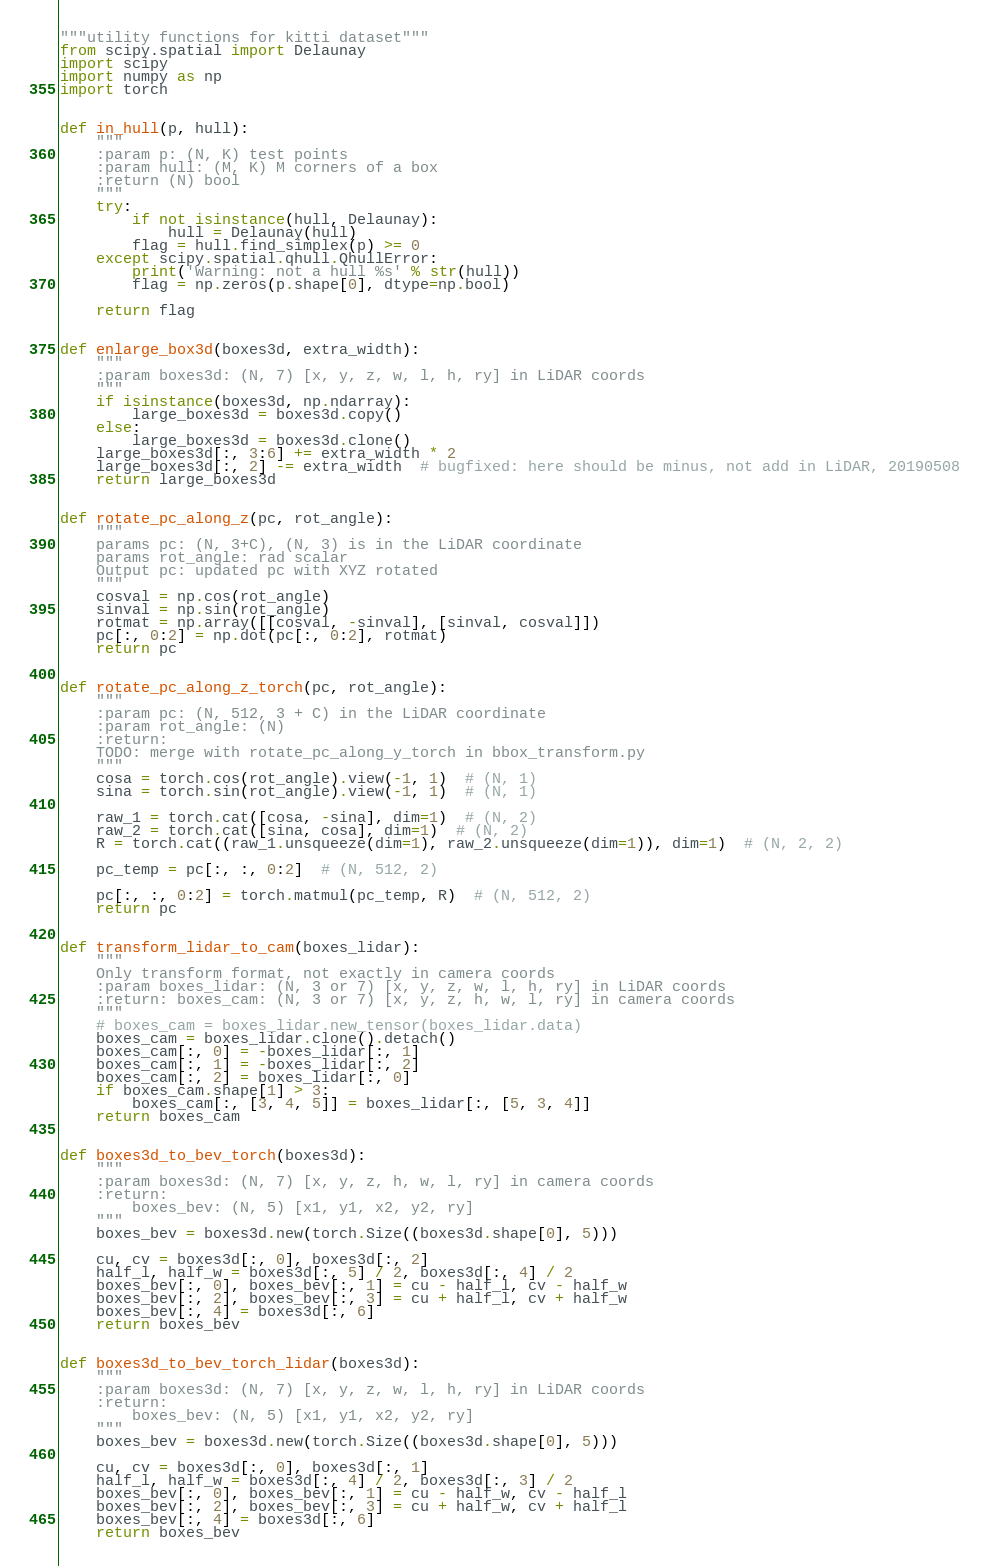<code> <loc_0><loc_0><loc_500><loc_500><_Python_>"""utility functions for kitti dataset"""
from scipy.spatial import Delaunay
import scipy
import numpy as np
import torch


def in_hull(p, hull):
    """
    :param p: (N, K) test points
    :param hull: (M, K) M corners of a box
    :return (N) bool
    """
    try:
        if not isinstance(hull, Delaunay):
            hull = Delaunay(hull)
        flag = hull.find_simplex(p) >= 0
    except scipy.spatial.qhull.QhullError:
        print('Warning: not a hull %s' % str(hull))
        flag = np.zeros(p.shape[0], dtype=np.bool)

    return flag


def enlarge_box3d(boxes3d, extra_width):
    """
    :param boxes3d: (N, 7) [x, y, z, w, l, h, ry] in LiDAR coords
    """
    if isinstance(boxes3d, np.ndarray):
        large_boxes3d = boxes3d.copy()
    else:
        large_boxes3d = boxes3d.clone()
    large_boxes3d[:, 3:6] += extra_width * 2
    large_boxes3d[:, 2] -= extra_width  # bugfixed: here should be minus, not add in LiDAR, 20190508
    return large_boxes3d


def rotate_pc_along_z(pc, rot_angle):
    """
    params pc: (N, 3+C), (N, 3) is in the LiDAR coordinate
    params rot_angle: rad scalar
    Output pc: updated pc with XYZ rotated
    """
    cosval = np.cos(rot_angle)
    sinval = np.sin(rot_angle)
    rotmat = np.array([[cosval, -sinval], [sinval, cosval]])
    pc[:, 0:2] = np.dot(pc[:, 0:2], rotmat)
    return pc


def rotate_pc_along_z_torch(pc, rot_angle):
    """
    :param pc: (N, 512, 3 + C) in the LiDAR coordinate
    :param rot_angle: (N)
    :return:
    TODO: merge with rotate_pc_along_y_torch in bbox_transform.py
    """
    cosa = torch.cos(rot_angle).view(-1, 1)  # (N, 1)
    sina = torch.sin(rot_angle).view(-1, 1)  # (N, 1)

    raw_1 = torch.cat([cosa, -sina], dim=1)  # (N, 2)
    raw_2 = torch.cat([sina, cosa], dim=1)  # (N, 2)
    R = torch.cat((raw_1.unsqueeze(dim=1), raw_2.unsqueeze(dim=1)), dim=1)  # (N, 2, 2)

    pc_temp = pc[:, :, 0:2]  # (N, 512, 2)

    pc[:, :, 0:2] = torch.matmul(pc_temp, R)  # (N, 512, 2)
    return pc


def transform_lidar_to_cam(boxes_lidar):
    """
    Only transform format, not exactly in camera coords
    :param boxes_lidar: (N, 3 or 7) [x, y, z, w, l, h, ry] in LiDAR coords
    :return: boxes_cam: (N, 3 or 7) [x, y, z, h, w, l, ry] in camera coords
    """
    # boxes_cam = boxes_lidar.new_tensor(boxes_lidar.data)
    boxes_cam = boxes_lidar.clone().detach()
    boxes_cam[:, 0] = -boxes_lidar[:, 1]
    boxes_cam[:, 1] = -boxes_lidar[:, 2]
    boxes_cam[:, 2] = boxes_lidar[:, 0]
    if boxes_cam.shape[1] > 3:
        boxes_cam[:, [3, 4, 5]] = boxes_lidar[:, [5, 3, 4]]
    return boxes_cam


def boxes3d_to_bev_torch(boxes3d):
    """
    :param boxes3d: (N, 7) [x, y, z, h, w, l, ry] in camera coords
    :return:
        boxes_bev: (N, 5) [x1, y1, x2, y2, ry]
    """
    boxes_bev = boxes3d.new(torch.Size((boxes3d.shape[0], 5)))

    cu, cv = boxes3d[:, 0], boxes3d[:, 2]
    half_l, half_w = boxes3d[:, 5] / 2, boxes3d[:, 4] / 2
    boxes_bev[:, 0], boxes_bev[:, 1] = cu - half_l, cv - half_w
    boxes_bev[:, 2], boxes_bev[:, 3] = cu + half_l, cv + half_w
    boxes_bev[:, 4] = boxes3d[:, 6]
    return boxes_bev


def boxes3d_to_bev_torch_lidar(boxes3d):
    """
    :param boxes3d: (N, 7) [x, y, z, w, l, h, ry] in LiDAR coords
    :return:
        boxes_bev: (N, 5) [x1, y1, x2, y2, ry]
    """
    boxes_bev = boxes3d.new(torch.Size((boxes3d.shape[0], 5)))

    cu, cv = boxes3d[:, 0], boxes3d[:, 1]
    half_l, half_w = boxes3d[:, 4] / 2, boxes3d[:, 3] / 2
    boxes_bev[:, 0], boxes_bev[:, 1] = cu - half_w, cv - half_l
    boxes_bev[:, 2], boxes_bev[:, 3] = cu + half_w, cv + half_l
    boxes_bev[:, 4] = boxes3d[:, 6]
    return boxes_bev
</code> 